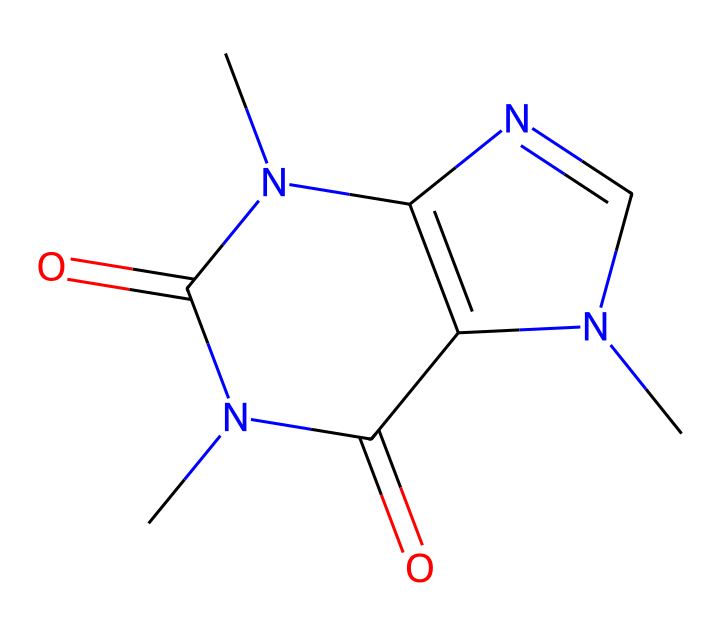What is the molecular formula of caffeine? To determine the molecular formula, we need to count the number of each type of atom in the SMILES representation. The SMILES indicates that caffeine contains 8 carbon (C) atoms, 10 hydrogen (H) atoms, 4 nitrogen (N) atoms, and 2 oxygen (O) atoms. Thus, the molecular formula is C8H10N4O2.
Answer: C8H10N4O2 How many rings are present in the caffeine structure? By analyzing the structure represented in the SMILES, we can see that there are two ring structures present. They are identified by the nitrogen and carbon atoms connecting back to themselves, forming cycles.
Answer: 2 What type of chemical is caffeine? Caffeine is classified as an alkaloid, which are nitrogen-containing compounds derived from plants. Its distinctive structure includes nitrogen atoms, which is characteristic of many alkaloids.
Answer: alkaloid How many nitrogen atoms are in caffeine? Examining the SMILES structure, we can count a total of 4 nitrogen (N) atoms present in the caffeine molecule.
Answer: 4 What element is primarily responsible for caffeine's stimulating effects? The nitrogen atoms in caffeine are responsible for its interaction with neurotransmitter receptors in the brain, leading to stimulant effects. Thus, nitrogen is the key element for this property.
Answer: nitrogen What is the relationship between caffeine's structure and its psychoactive properties? Caffeine's structure allows it to block adenosine receptors in the brain, which affects neurotransmitter activity and leads to increased arousal and alertness. Therefore, the key relationship is its ability to structurally mimic adenosine.
Answer: adenosine receptors 